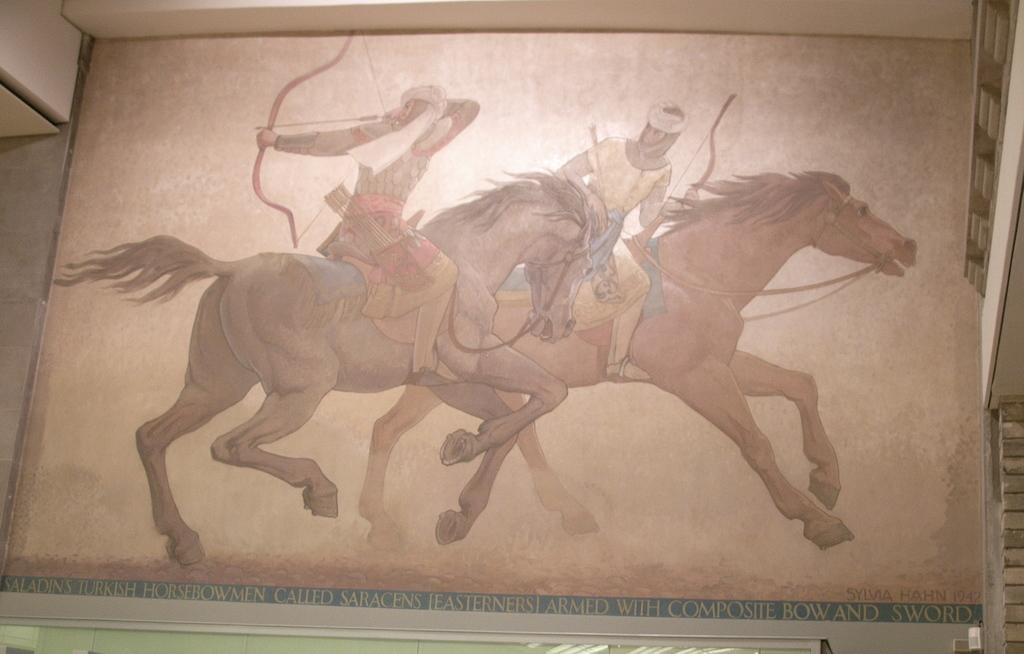What is the main subject of the wall painting in the image? The wall painting depicts two people riding horses. What is the location of the wall painting in the image? The wall painting is on the right side of the image. What can be seen on the wall in the image? There is a wall painting depicting two people riding horses. What type of steel structure is visible in the image? There is no steel structure present in the image; it only features a wall painting of two people riding horses. 